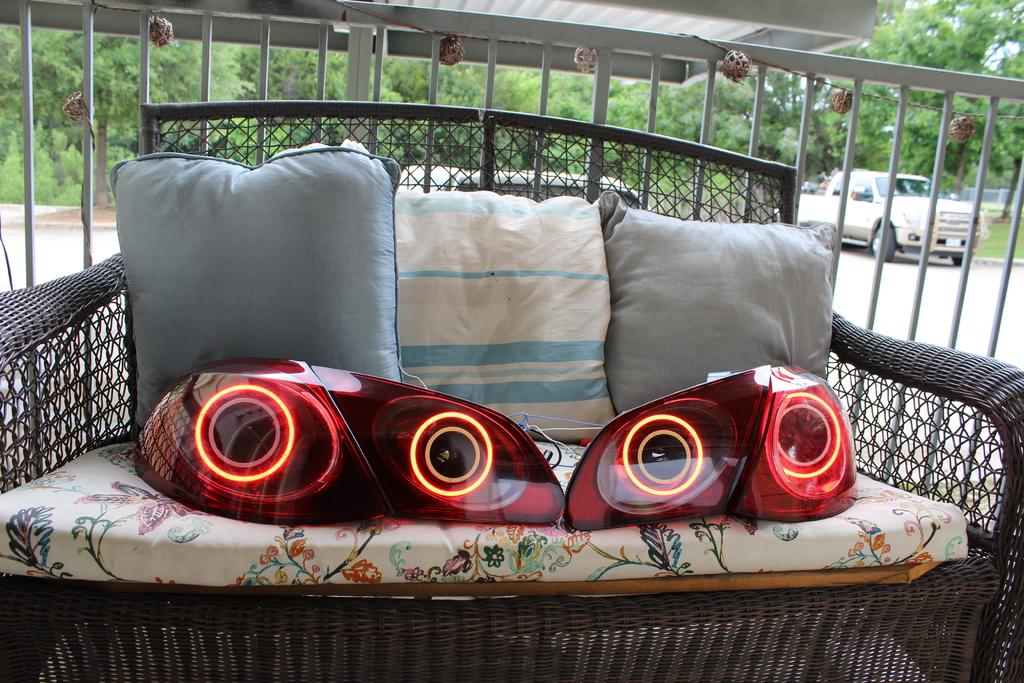What type of furniture is in the image? There is a sofa in the image. What is on the sofa? There are pillows and other objects on the sofa. What can be seen in the background of the image? There are vehicles, trees, grass, and other objects visible in the background of the image. What actor is performing on the sofa in the image? There is no actor performing on the sofa in the image. What type of writing can be seen on the pillows in the image? There is no writing visible on the pillows in the image. 